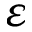Convert formula to latex. <formula><loc_0><loc_0><loc_500><loc_500>\varepsilon</formula> 